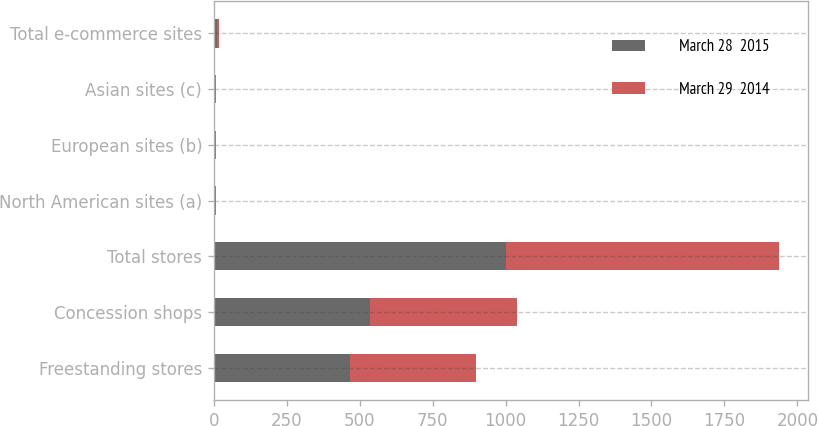<chart> <loc_0><loc_0><loc_500><loc_500><stacked_bar_chart><ecel><fcel>Freestanding stores<fcel>Concession shops<fcel>Total stores<fcel>North American sites (a)<fcel>European sites (b)<fcel>Asian sites (c)<fcel>Total e-commerce sites<nl><fcel>March 28  2015<fcel>466<fcel>536<fcel>1002<fcel>3<fcel>3<fcel>4<fcel>10<nl><fcel>March 29  2014<fcel>433<fcel>503<fcel>936<fcel>3<fcel>3<fcel>2<fcel>8<nl></chart> 